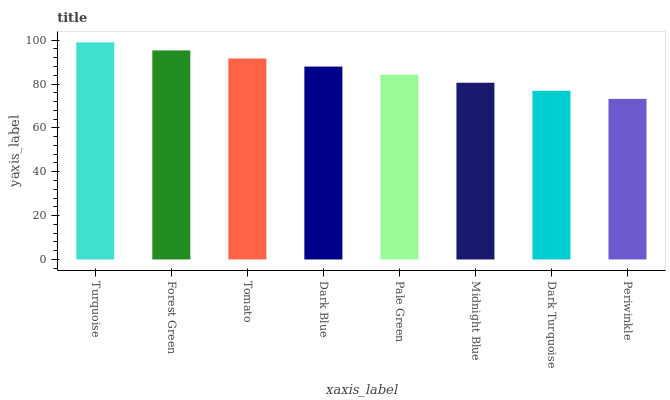Is Periwinkle the minimum?
Answer yes or no. Yes. Is Turquoise the maximum?
Answer yes or no. Yes. Is Forest Green the minimum?
Answer yes or no. No. Is Forest Green the maximum?
Answer yes or no. No. Is Turquoise greater than Forest Green?
Answer yes or no. Yes. Is Forest Green less than Turquoise?
Answer yes or no. Yes. Is Forest Green greater than Turquoise?
Answer yes or no. No. Is Turquoise less than Forest Green?
Answer yes or no. No. Is Dark Blue the high median?
Answer yes or no. Yes. Is Pale Green the low median?
Answer yes or no. Yes. Is Dark Turquoise the high median?
Answer yes or no. No. Is Dark Turquoise the low median?
Answer yes or no. No. 